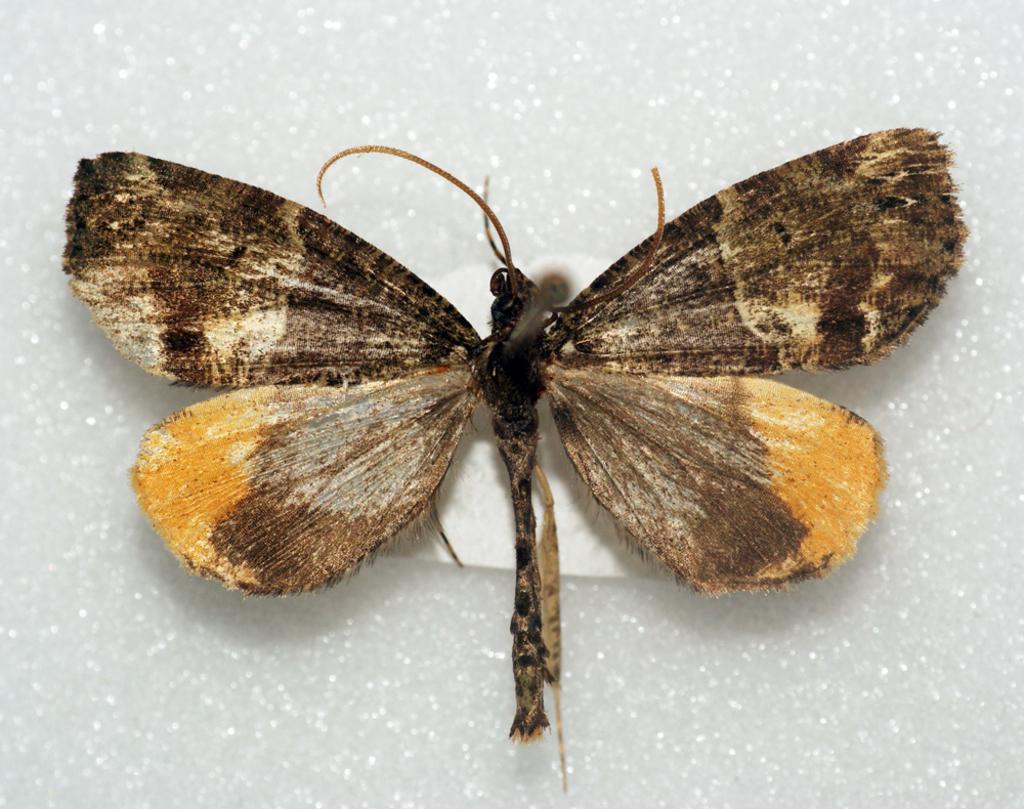Describe this image in one or two sentences. We can see insect on the white surface. 